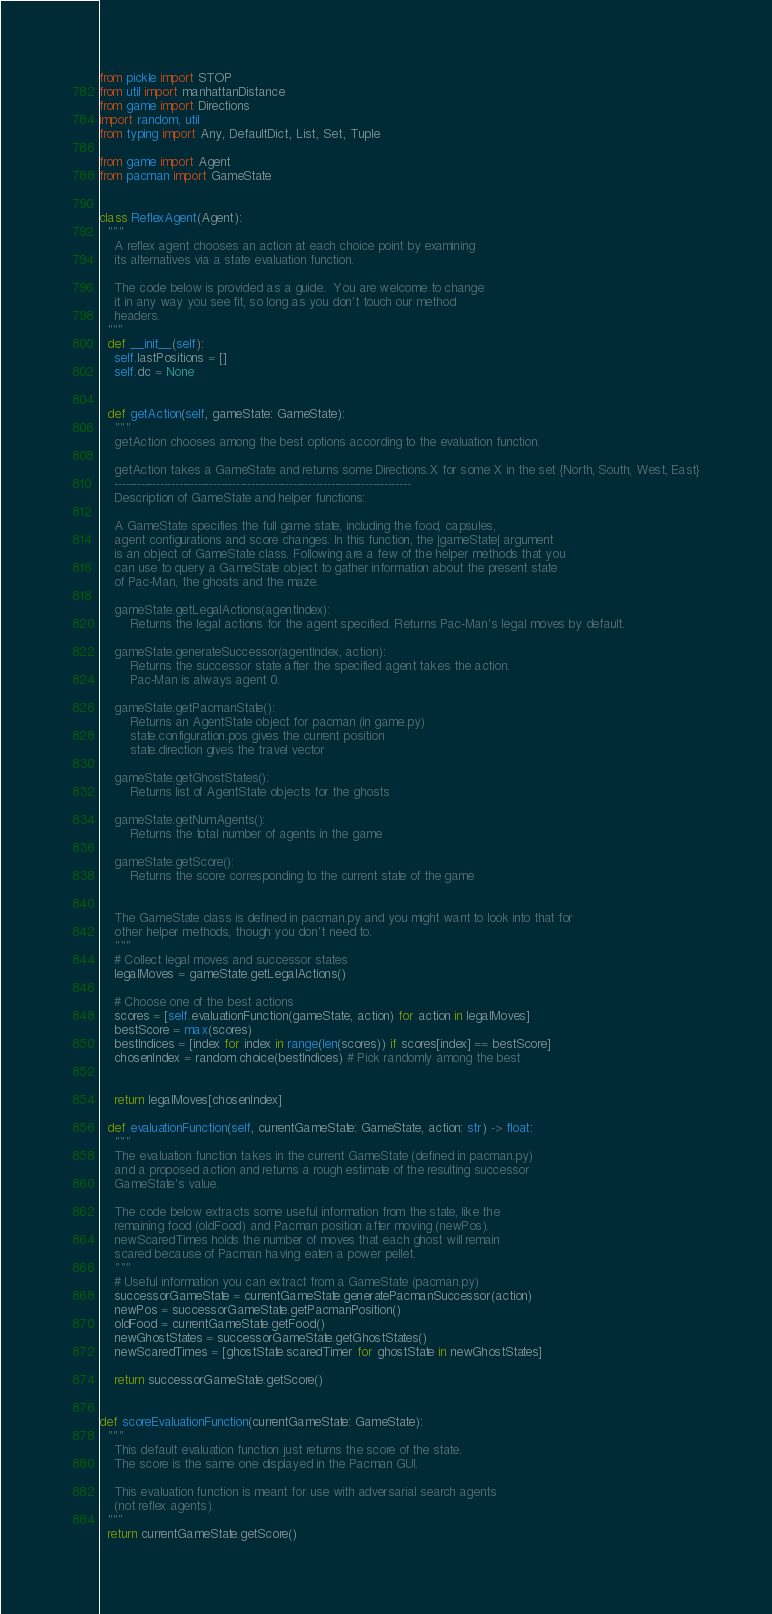Convert code to text. <code><loc_0><loc_0><loc_500><loc_500><_Python_>from pickle import STOP
from util import manhattanDistance
from game import Directions
import random, util
from typing import Any, DefaultDict, List, Set, Tuple

from game import Agent
from pacman import GameState


class ReflexAgent(Agent):
  """
    A reflex agent chooses an action at each choice point by examining
    its alternatives via a state evaluation function.

    The code below is provided as a guide.  You are welcome to change
    it in any way you see fit, so long as you don't touch our method
    headers.
  """
  def __init__(self):
    self.lastPositions = []
    self.dc = None


  def getAction(self, gameState: GameState):
    """
    getAction chooses among the best options according to the evaluation function.

    getAction takes a GameState and returns some Directions.X for some X in the set {North, South, West, East}
    ------------------------------------------------------------------------------
    Description of GameState and helper functions:

    A GameState specifies the full game state, including the food, capsules,
    agent configurations and score changes. In this function, the |gameState| argument
    is an object of GameState class. Following are a few of the helper methods that you
    can use to query a GameState object to gather information about the present state
    of Pac-Man, the ghosts and the maze.

    gameState.getLegalActions(agentIndex):
        Returns the legal actions for the agent specified. Returns Pac-Man's legal moves by default.

    gameState.generateSuccessor(agentIndex, action):
        Returns the successor state after the specified agent takes the action.
        Pac-Man is always agent 0.

    gameState.getPacmanState():
        Returns an AgentState object for pacman (in game.py)
        state.configuration.pos gives the current position
        state.direction gives the travel vector

    gameState.getGhostStates():
        Returns list of AgentState objects for the ghosts

    gameState.getNumAgents():
        Returns the total number of agents in the game

    gameState.getScore():
        Returns the score corresponding to the current state of the game


    The GameState class is defined in pacman.py and you might want to look into that for
    other helper methods, though you don't need to.
    """
    # Collect legal moves and successor states
    legalMoves = gameState.getLegalActions()

    # Choose one of the best actions
    scores = [self.evaluationFunction(gameState, action) for action in legalMoves]
    bestScore = max(scores)
    bestIndices = [index for index in range(len(scores)) if scores[index] == bestScore]
    chosenIndex = random.choice(bestIndices) # Pick randomly among the best


    return legalMoves[chosenIndex]

  def evaluationFunction(self, currentGameState: GameState, action: str) -> float:
    """
    The evaluation function takes in the current GameState (defined in pacman.py)
    and a proposed action and returns a rough estimate of the resulting successor
    GameState's value.

    The code below extracts some useful information from the state, like the
    remaining food (oldFood) and Pacman position after moving (newPos).
    newScaredTimes holds the number of moves that each ghost will remain
    scared because of Pacman having eaten a power pellet.
    """
    # Useful information you can extract from a GameState (pacman.py)
    successorGameState = currentGameState.generatePacmanSuccessor(action)
    newPos = successorGameState.getPacmanPosition()
    oldFood = currentGameState.getFood()
    newGhostStates = successorGameState.getGhostStates()
    newScaredTimes = [ghostState.scaredTimer for ghostState in newGhostStates]

    return successorGameState.getScore()


def scoreEvaluationFunction(currentGameState: GameState):
  """
    This default evaluation function just returns the score of the state.
    The score is the same one displayed in the Pacman GUI.

    This evaluation function is meant for use with adversarial search agents
    (not reflex agents).
  """
  return currentGameState.getScore()
</code> 